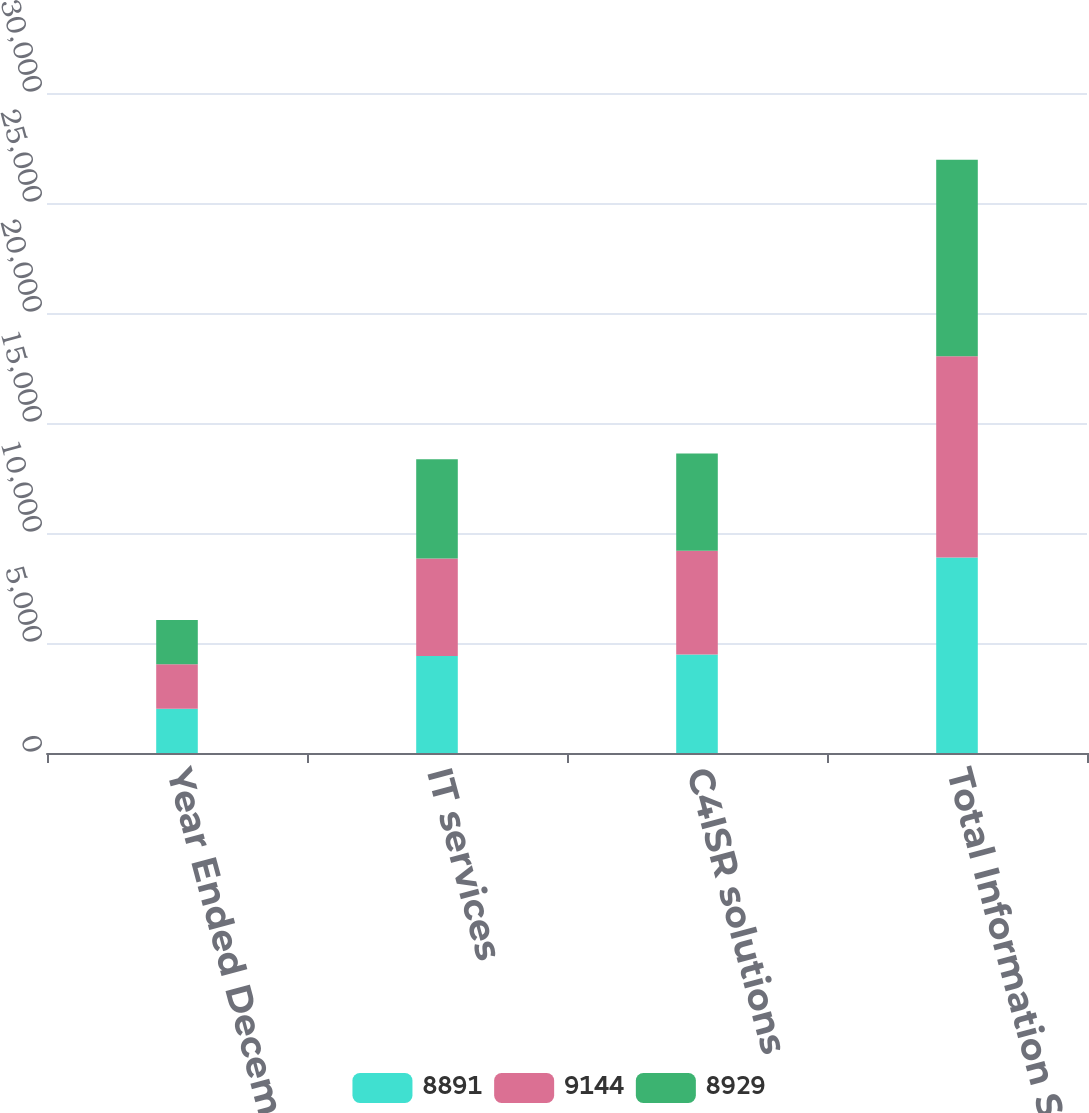Convert chart. <chart><loc_0><loc_0><loc_500><loc_500><stacked_bar_chart><ecel><fcel>Year Ended December 31<fcel>IT services<fcel>C4ISR solutions<fcel>Total Information Systems and<nl><fcel>8891<fcel>2017<fcel>4410<fcel>4481<fcel>8891<nl><fcel>9144<fcel>2016<fcel>4428<fcel>4716<fcel>9144<nl><fcel>8929<fcel>2015<fcel>4510<fcel>4419<fcel>8929<nl></chart> 